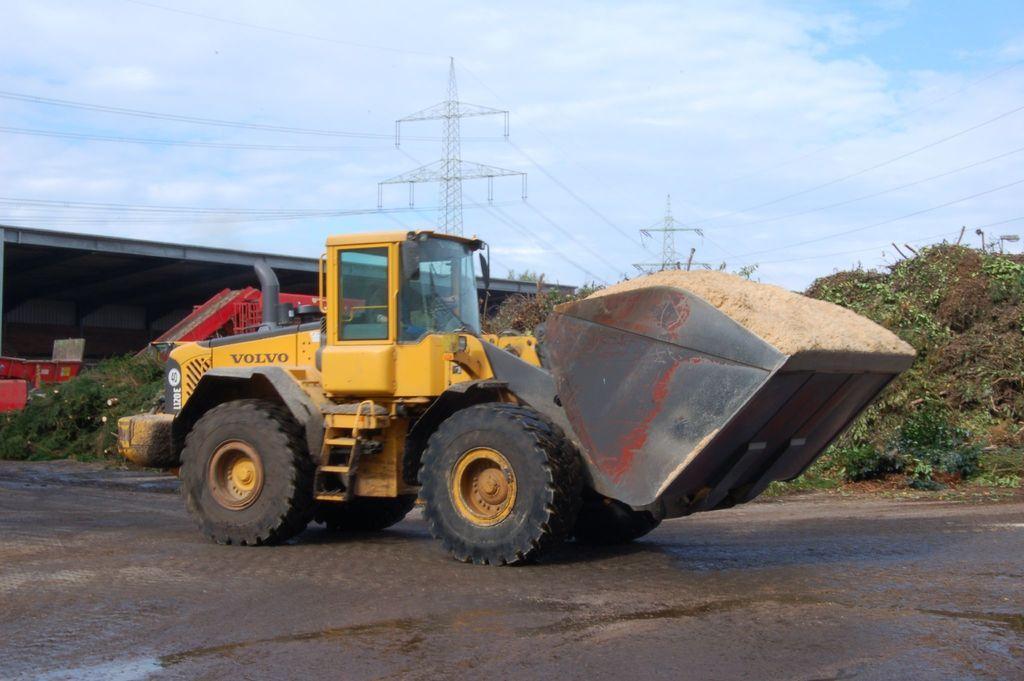In one or two sentences, can you explain what this image depicts? In this image in the center there is a vehicle which is yellow in colour with some text written on it. In the background there is grass on the ground and there is a bridge and there are towers with wires and the sky is cloudy. 